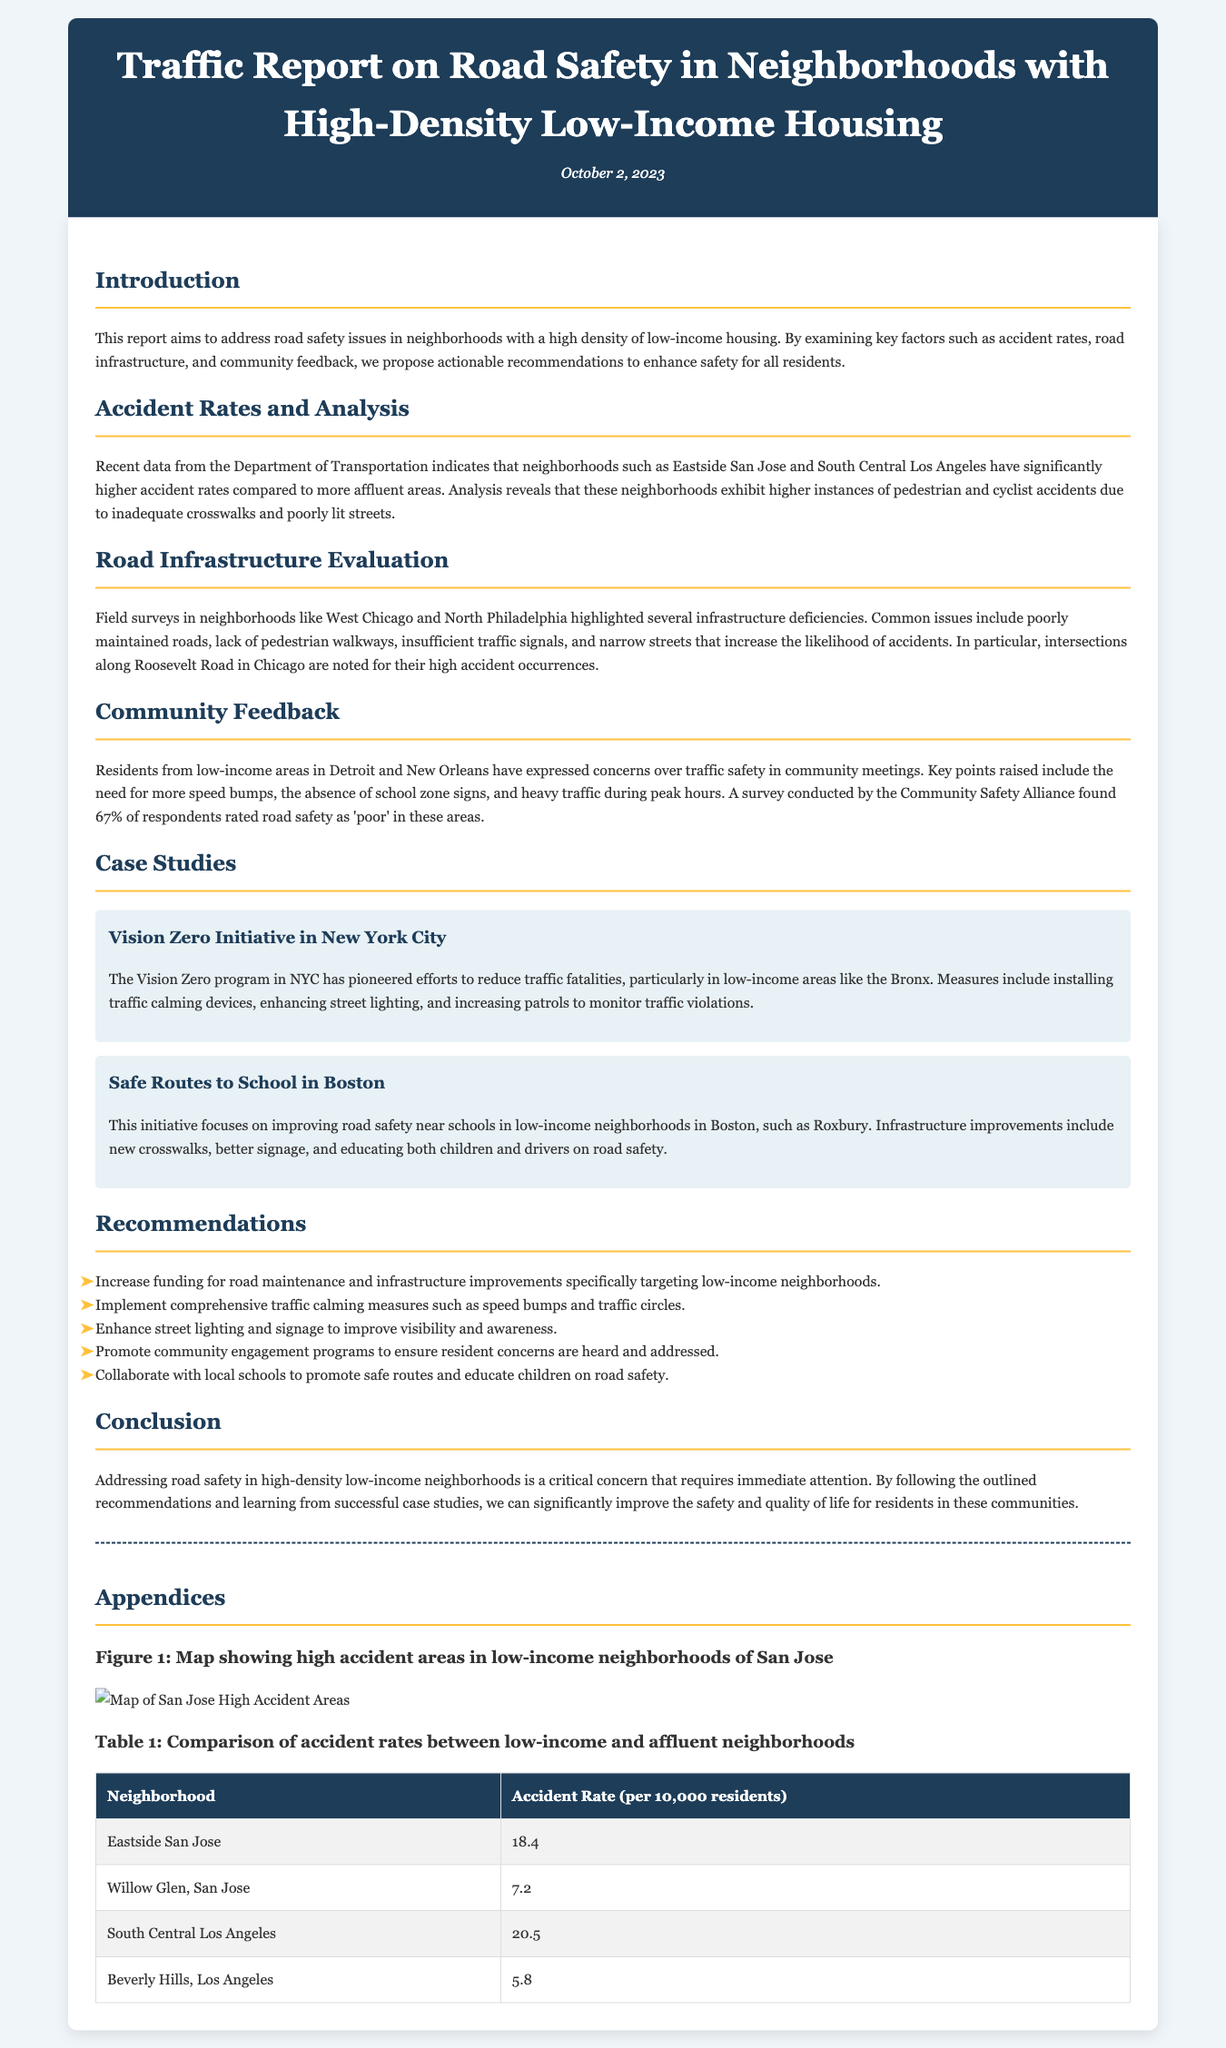What is the date of the report? The date of the report is mentioned in the header of the document as October 2, 2023.
Answer: October 2, 2023 Which neighborhood has the highest accident rate? The document states that South Central Los Angeles has an accident rate of 20.5 per 10,000 residents, which is the highest among the listed neighborhoods.
Answer: South Central Los Angeles What percentage of respondents rated road safety as 'poor'? According to the Community Safety Alliance survey, 67% of respondents expressed that road safety was 'poor' in low-income areas.
Answer: 67% What are speed bumps classified as in the document? Speed bumps are mentioned in the community feedback section as a needed traffic calming measure in low-income areas.
Answer: Traffic calming measures Which initiative is focused on improving road safety near schools? The report refers to the Safe Routes to School initiative, which aims to enhance safety near schools in low-income neighborhoods in Boston.
Answer: Safe Routes to School What is the common issue found in West Chicago according to the report? The report highlights poorly maintained roads as a common infrastructure deficiency found in West Chicago neighborhoods.
Answer: Poorly maintained roads Which program is mentioned as a successful case study for reducing traffic fatalities? The Vision Zero program in New York City is recognized as a successful effort to reduce traffic fatalities, particularly in low-income areas.
Answer: Vision Zero What is the recommended action related to community engagement? One of the recommendations is to promote community engagement programs to ensure resident concerns are heard and addressed.
Answer: Promote community engagement programs 